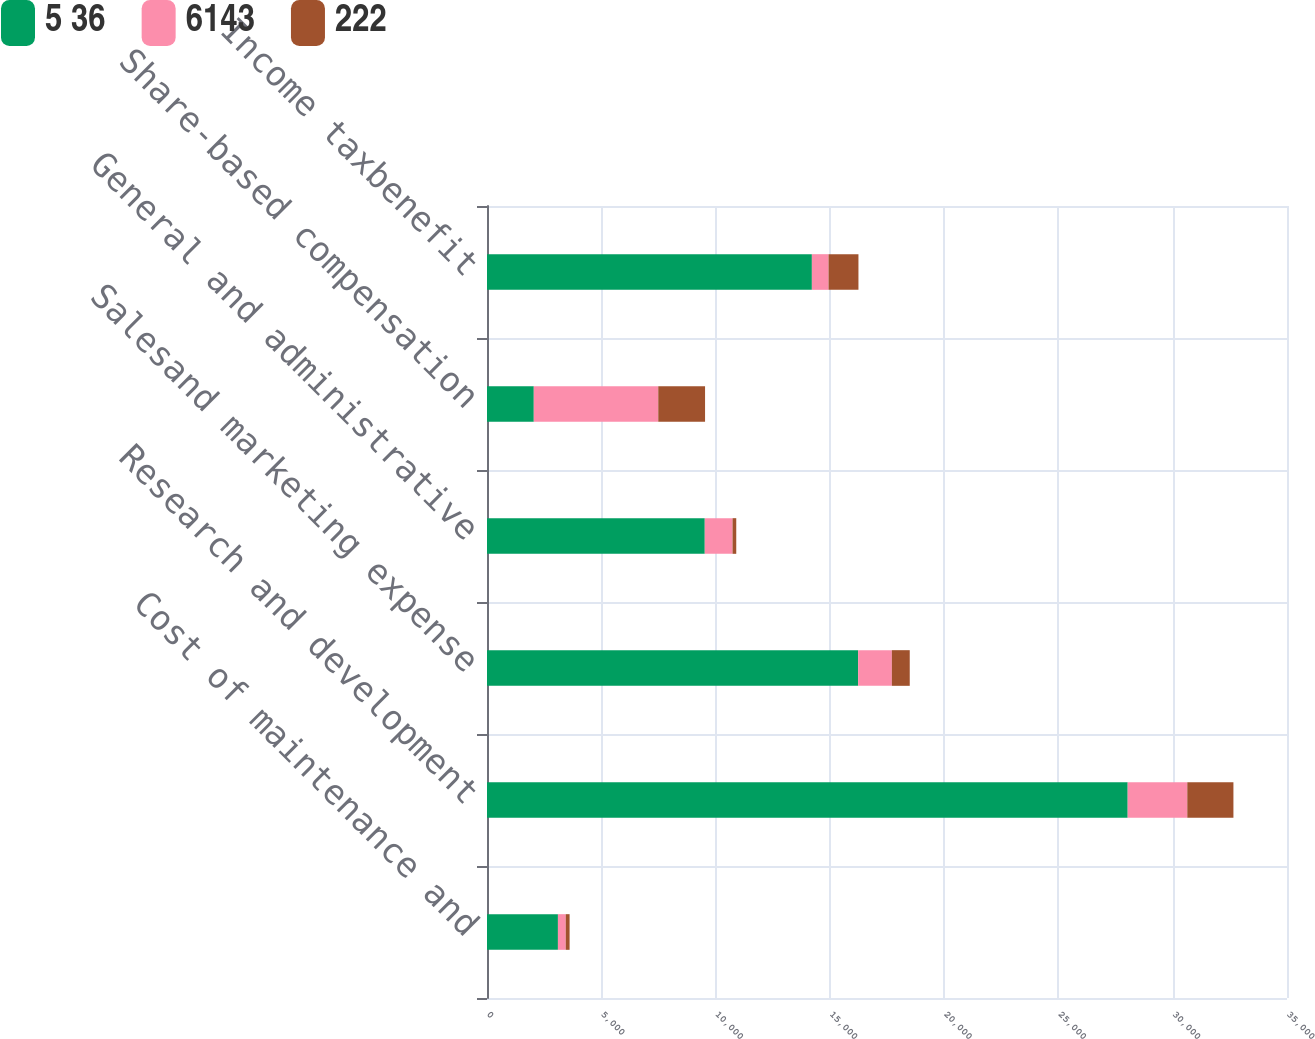Convert chart to OTSL. <chart><loc_0><loc_0><loc_500><loc_500><stacked_bar_chart><ecel><fcel>Cost of maintenance and<fcel>Research and development<fcel>Salesand marketing expense<fcel>General and administrative<fcel>Share-based compensation<fcel>Income taxbenefit<nl><fcel>5 36<fcel>3103<fcel>28030<fcel>16237<fcel>9527<fcel>2047<fcel>14213<nl><fcel>6143<fcel>342<fcel>2608<fcel>1475<fcel>1215<fcel>5446<fcel>730<nl><fcel>222<fcel>169<fcel>2018<fcel>783<fcel>163<fcel>2047<fcel>1308<nl></chart> 